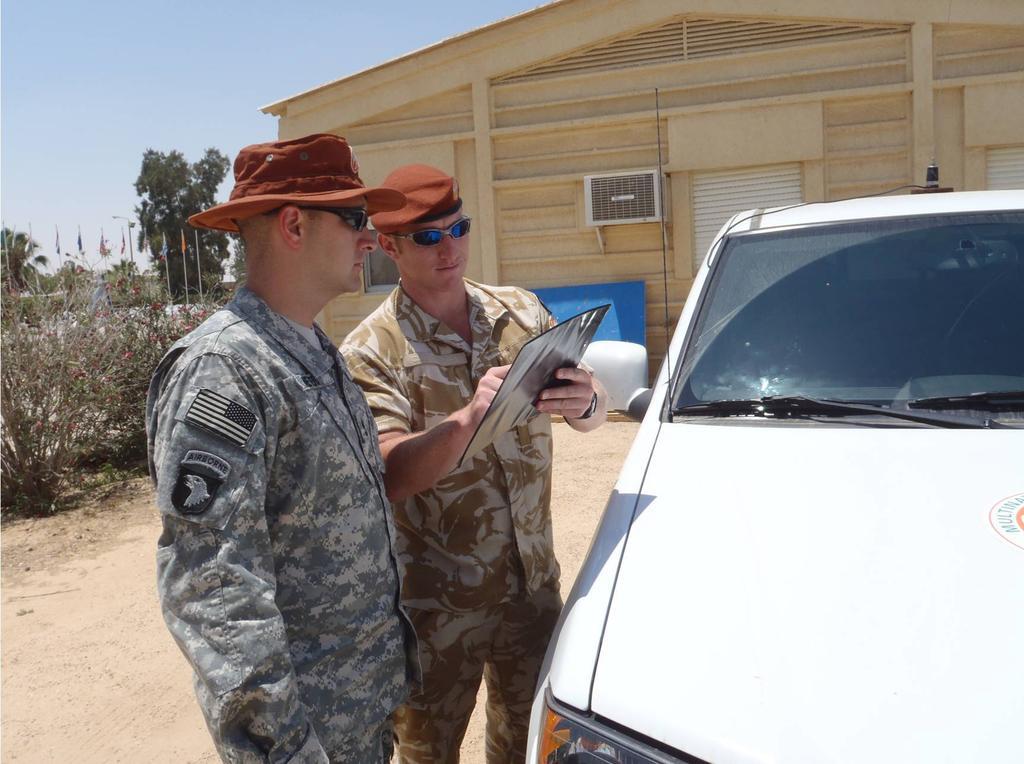How would you summarize this image in a sentence or two? In the middle two army men are standing and looking into the paper, they wore caps, on the right side there is a vehicle in white color. In the middle it is a wooden house, on the left side there are trees. 